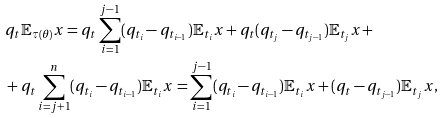Convert formula to latex. <formula><loc_0><loc_0><loc_500><loc_500>& q _ { t } \mathbb { E } _ { \tau ( \theta ) } x = q _ { t } \sum _ { i = 1 } ^ { j - 1 } ( q _ { t _ { i } } - q _ { t _ { i - 1 } } ) \mathbb { E } _ { t _ { i } } x + q _ { t } ( q _ { t _ { j } } - q _ { t _ { j - 1 } } ) \mathbb { E } _ { t _ { j } } x + \\ & + q _ { t } \sum _ { i = j + 1 } ^ { n } ( q _ { t _ { i } } - q _ { t _ { i - 1 } } ) \mathbb { E } _ { t _ { i } } x = \sum _ { i = 1 } ^ { j - 1 } ( q _ { t _ { i } } - q _ { t _ { i - 1 } } ) \mathbb { E } _ { t _ { i } } x + ( q _ { t } - q _ { t _ { j - 1 } } ) \mathbb { E } _ { t _ { j } } x ,</formula> 